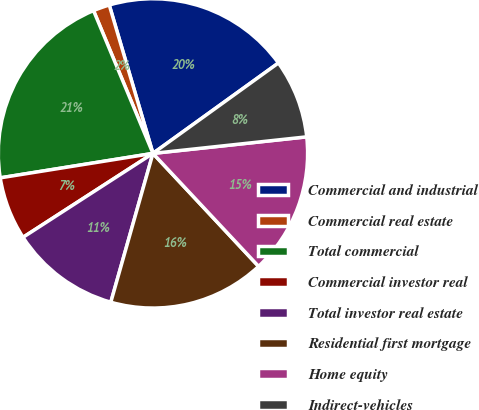Convert chart. <chart><loc_0><loc_0><loc_500><loc_500><pie_chart><fcel>Commercial and industrial<fcel>Commercial real estate<fcel>Total commercial<fcel>Commercial investor real<fcel>Total investor real estate<fcel>Residential first mortgage<fcel>Home equity<fcel>Indirect-vehicles<nl><fcel>19.62%<fcel>1.72%<fcel>21.25%<fcel>6.6%<fcel>11.48%<fcel>16.36%<fcel>14.74%<fcel>8.23%<nl></chart> 